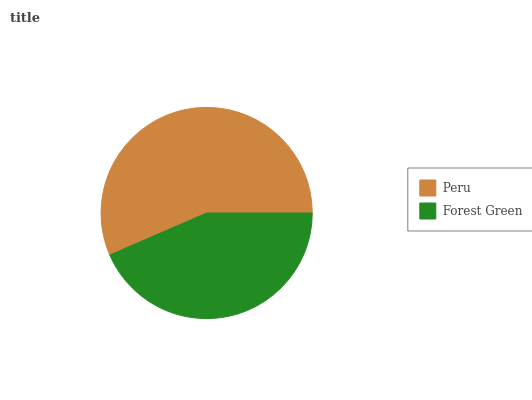Is Forest Green the minimum?
Answer yes or no. Yes. Is Peru the maximum?
Answer yes or no. Yes. Is Forest Green the maximum?
Answer yes or no. No. Is Peru greater than Forest Green?
Answer yes or no. Yes. Is Forest Green less than Peru?
Answer yes or no. Yes. Is Forest Green greater than Peru?
Answer yes or no. No. Is Peru less than Forest Green?
Answer yes or no. No. Is Peru the high median?
Answer yes or no. Yes. Is Forest Green the low median?
Answer yes or no. Yes. Is Forest Green the high median?
Answer yes or no. No. Is Peru the low median?
Answer yes or no. No. 